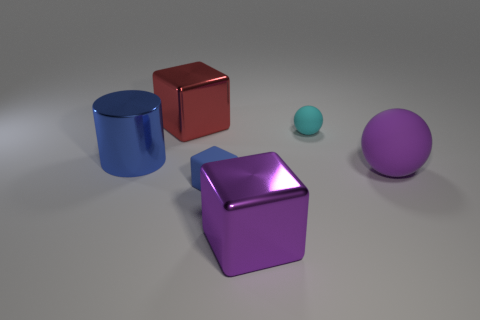There is a shiny object that is the same color as the large matte object; what is its shape?
Your answer should be very brief. Cube. Is there any other thing that has the same shape as the blue shiny thing?
Offer a very short reply. No. How many other things are the same size as the matte cube?
Provide a succinct answer. 1. There is a blue object to the left of the large red metal block; does it have the same size as the rubber thing that is on the left side of the big purple cube?
Ensure brevity in your answer.  No. How many objects are either big red cubes or cubes in front of the blue cylinder?
Keep it short and to the point. 3. How big is the purple object on the left side of the large purple rubber thing?
Ensure brevity in your answer.  Large. Is the number of small blue matte things behind the small blue matte object less than the number of metal cylinders behind the purple ball?
Provide a short and direct response. Yes. What is the material of the large object that is both to the left of the tiny rubber sphere and to the right of the red metallic thing?
Offer a terse response. Metal. What is the shape of the red shiny thing that is to the left of the large purple object to the right of the large purple metallic cube?
Ensure brevity in your answer.  Cube. Is the color of the metal cylinder the same as the tiny rubber block?
Ensure brevity in your answer.  Yes. 